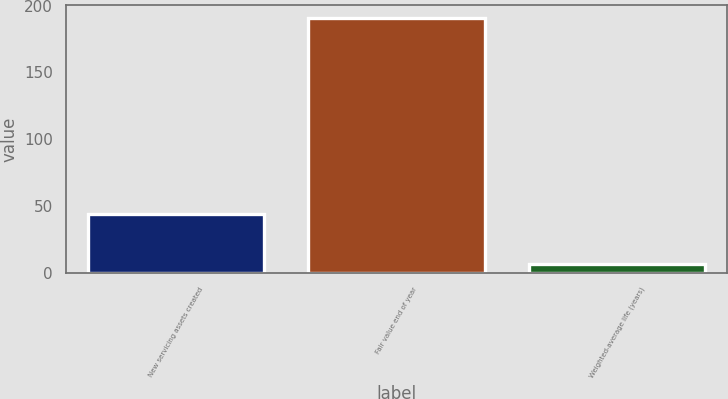Convert chart. <chart><loc_0><loc_0><loc_500><loc_500><bar_chart><fcel>New servicing assets created<fcel>Fair value end of year<fcel>Weighted-average life (years)<nl><fcel>44<fcel>191<fcel>7.1<nl></chart> 